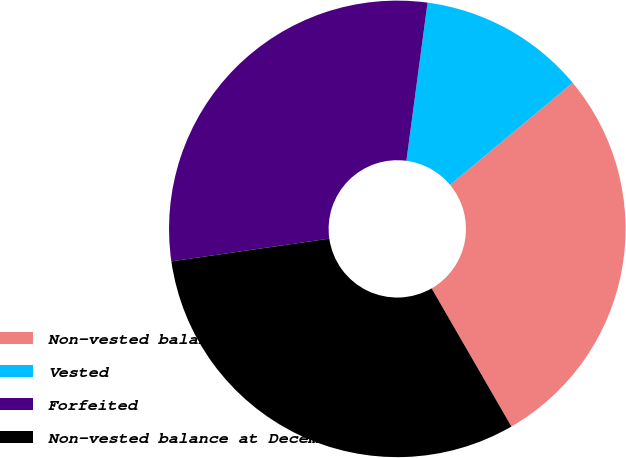<chart> <loc_0><loc_0><loc_500><loc_500><pie_chart><fcel>Non-vested balance at January<fcel>Vested<fcel>Forfeited<fcel>Non-vested balance at December<nl><fcel>27.72%<fcel>11.83%<fcel>29.39%<fcel>31.06%<nl></chart> 